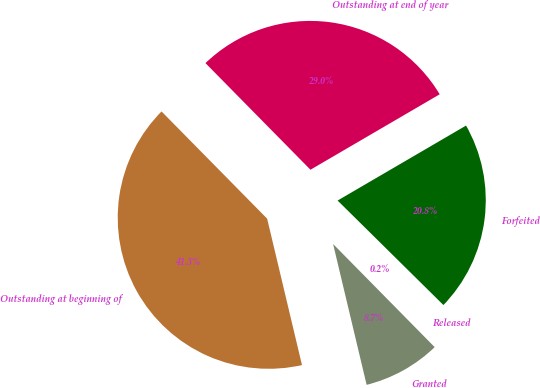<chart> <loc_0><loc_0><loc_500><loc_500><pie_chart><fcel>Outstanding at beginning of<fcel>Granted<fcel>Released<fcel>Forfeited<fcel>Outstanding at end of year<nl><fcel>41.34%<fcel>8.66%<fcel>0.22%<fcel>20.81%<fcel>28.97%<nl></chart> 